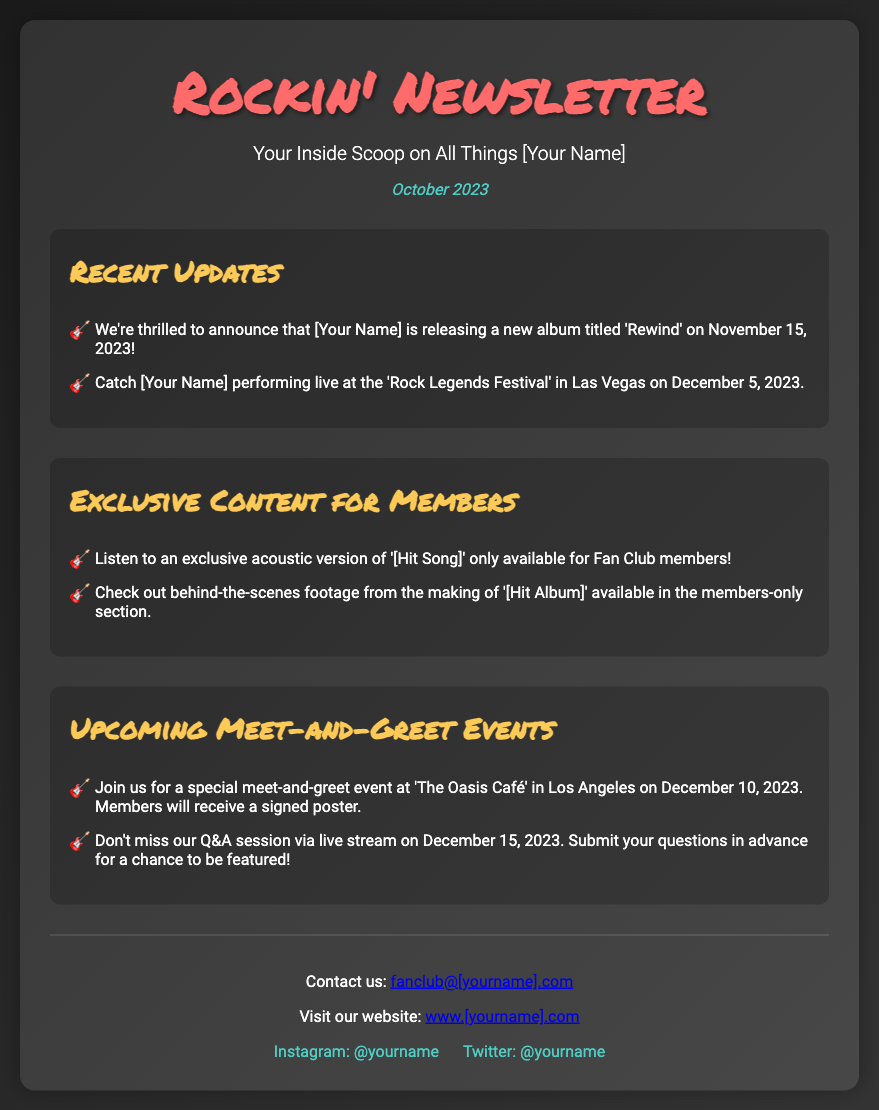What is the title of the new album? The document states that the new album is titled 'Rewind'.
Answer: Rewind When will [Your Name] perform at the 'Rock Legends Festival'? According to the document, [Your Name] will perform live at the festival on December 5, 2023.
Answer: December 5, 2023 What exclusive content is available for members related to '[Hit Song]'? The newsletter mentions an exclusive acoustic version of '[Hit Song]' available only for Fan Club members.
Answer: Exclusive acoustic version What is the date of the meet-and-greet event at 'The Oasis Café'? The document indicates that the meet-and-greet event is on December 10, 2023.
Answer: December 10, 2023 What special item will members receive at the meet-and-greet event? The document specifies that members will receive a signed poster at the event.
Answer: Signed poster How can members submit questions for the live Q&A session? The document states that members should submit their questions in advance for a chance to be featured.
Answer: Submit in advance What is included in the behind-the-scenes footage for members? It mentions that the behind-the-scenes footage is from the making of '[Hit Album]'.
Answer: Making of '[Hit Album]' Which social media platform is mentioned for [Your Name]? The document mentions Instagram as a social media platform.
Answer: Instagram 